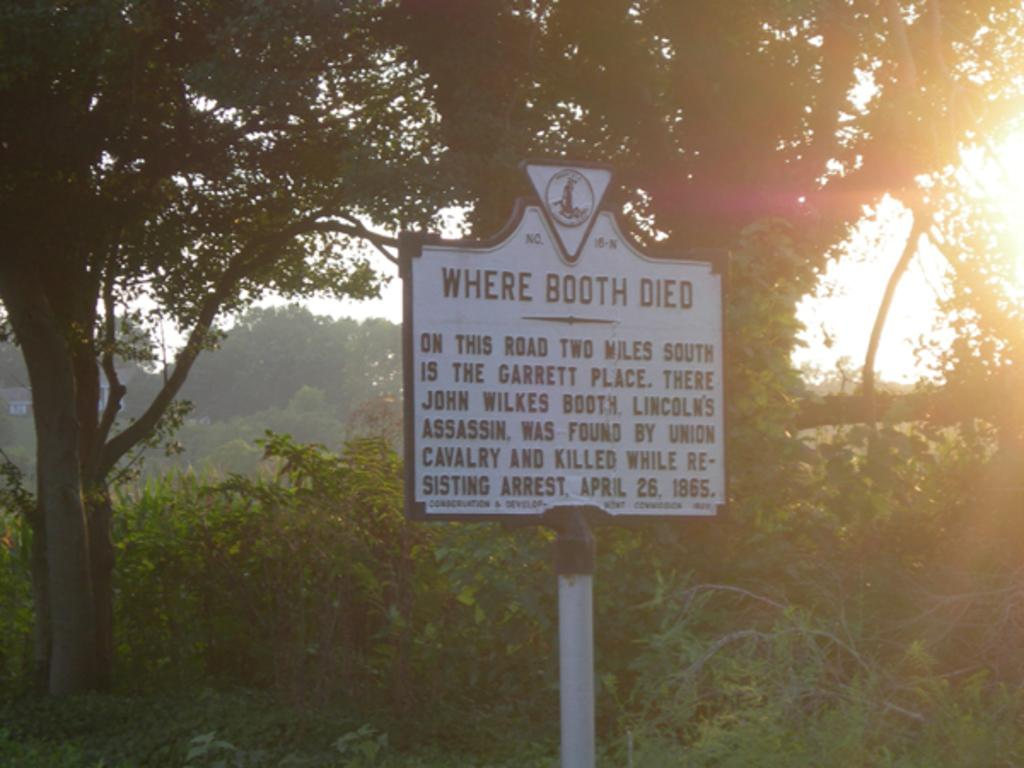What is the main object in the image? There is a board in the image. What can be seen in the background of the image? Trees are visible in the background of the image. Is the governor driving the board in the image? There is no governor or driving activity present in the image. How much salt is on the board in the image? There is no salt visible on the board in the image. 